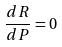<formula> <loc_0><loc_0><loc_500><loc_500>\frac { d R } { d P } = 0</formula> 